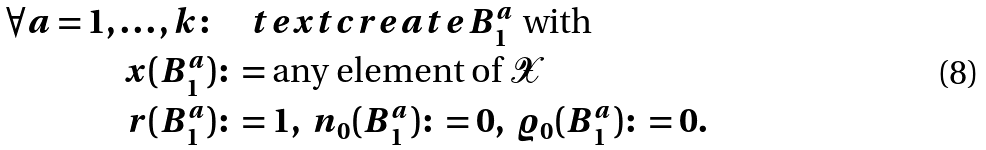<formula> <loc_0><loc_0><loc_500><loc_500>\forall a = 1 , \dots , k \colon & \quad t e x t { c r e a t e } B _ { 1 } ^ { a } \text { with} \\ x ( B _ { 1 } ^ { a } ) & \colon = \text {any element of } \mathcal { X } \\ r ( B _ { 1 } ^ { a } ) & \colon = 1 , \ n _ { 0 } ( B _ { 1 } ^ { a } ) \colon = 0 , \ \varrho _ { 0 } ( B _ { 1 } ^ { a } ) \colon = 0 .</formula> 